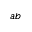<formula> <loc_0><loc_0><loc_500><loc_500>a b</formula> 